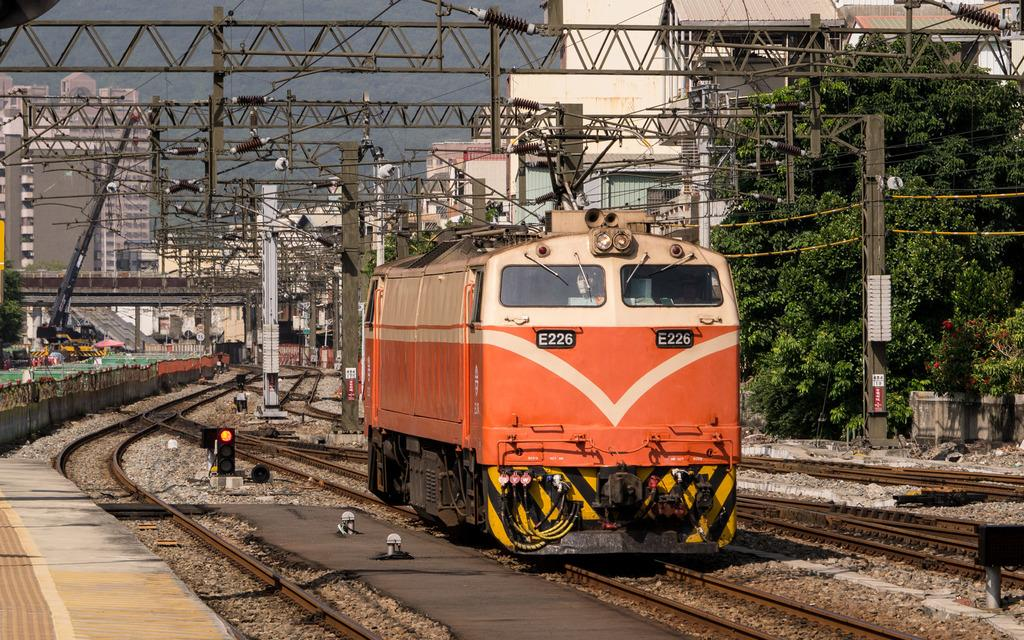<image>
Summarize the visual content of the image. a train that has E226 on the front of it 